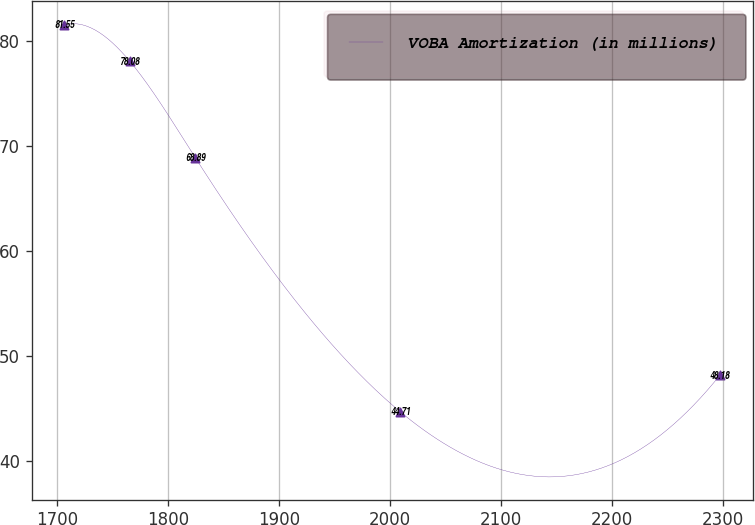Convert chart. <chart><loc_0><loc_0><loc_500><loc_500><line_chart><ecel><fcel>VOBA Amortization (in millions)<nl><fcel>1706.36<fcel>81.55<nl><fcel>1765.43<fcel>78.08<nl><fcel>1824.5<fcel>68.89<nl><fcel>2009.11<fcel>44.71<nl><fcel>2297.08<fcel>48.18<nl></chart> 